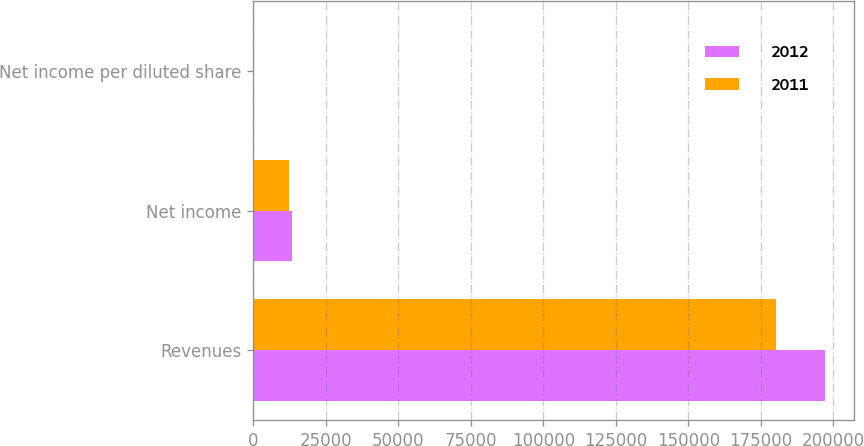Convert chart. <chart><loc_0><loc_0><loc_500><loc_500><stacked_bar_chart><ecel><fcel>Revenues<fcel>Net income<fcel>Net income per diluted share<nl><fcel>2012<fcel>197174<fcel>13220<fcel>0.14<nl><fcel>2011<fcel>180155<fcel>12107<fcel>0.11<nl></chart> 